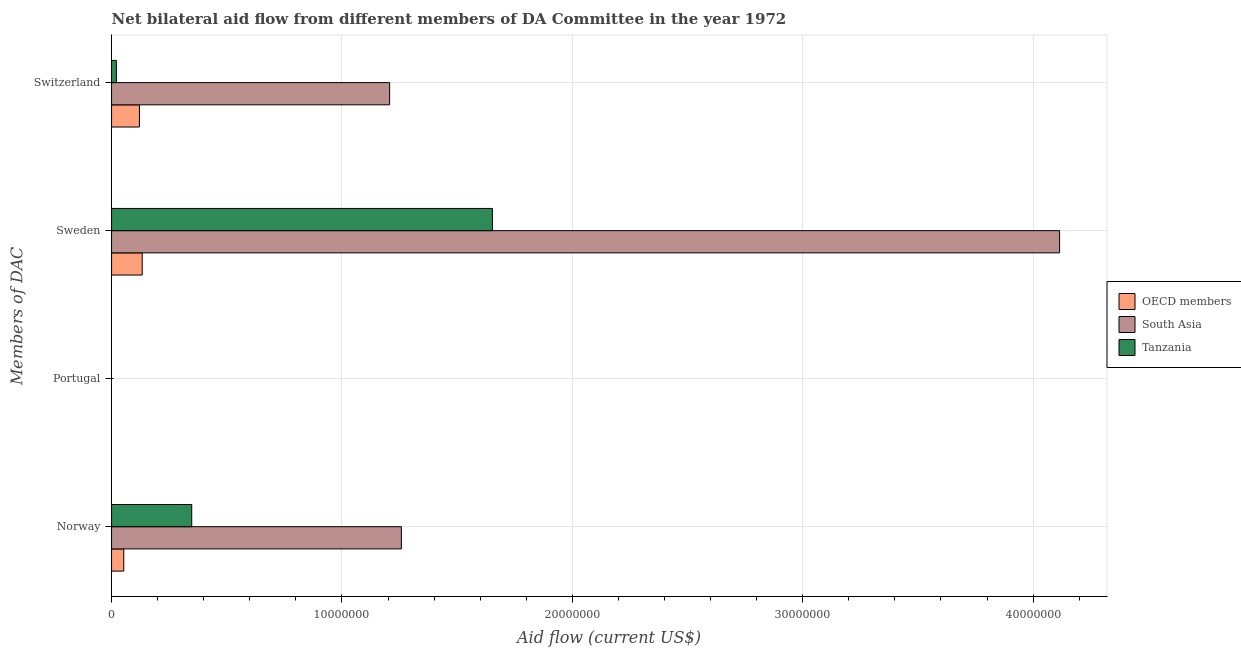What is the label of the 1st group of bars from the top?
Offer a very short reply. Switzerland. What is the amount of aid given by sweden in Tanzania?
Offer a very short reply. 1.65e+07. Across all countries, what is the maximum amount of aid given by norway?
Your answer should be very brief. 1.26e+07. Across all countries, what is the minimum amount of aid given by sweden?
Offer a terse response. 1.33e+06. What is the total amount of aid given by sweden in the graph?
Offer a terse response. 5.90e+07. What is the difference between the amount of aid given by norway in OECD members and that in Tanzania?
Ensure brevity in your answer.  -2.95e+06. What is the difference between the amount of aid given by switzerland in OECD members and the amount of aid given by portugal in South Asia?
Provide a succinct answer. 1.21e+06. What is the average amount of aid given by norway per country?
Ensure brevity in your answer.  5.53e+06. What is the difference between the amount of aid given by switzerland and amount of aid given by norway in OECD members?
Your answer should be very brief. 6.80e+05. What is the ratio of the amount of aid given by norway in Tanzania to that in South Asia?
Make the answer very short. 0.28. What is the difference between the highest and the second highest amount of aid given by switzerland?
Give a very brief answer. 1.09e+07. What is the difference between the highest and the lowest amount of aid given by norway?
Keep it short and to the point. 1.20e+07. In how many countries, is the amount of aid given by norway greater than the average amount of aid given by norway taken over all countries?
Ensure brevity in your answer.  1. Is the sum of the amount of aid given by norway in OECD members and South Asia greater than the maximum amount of aid given by portugal across all countries?
Your answer should be compact. Yes. Where does the legend appear in the graph?
Provide a succinct answer. Center right. What is the title of the graph?
Offer a very short reply. Net bilateral aid flow from different members of DA Committee in the year 1972. What is the label or title of the X-axis?
Keep it short and to the point. Aid flow (current US$). What is the label or title of the Y-axis?
Offer a terse response. Members of DAC. What is the Aid flow (current US$) in OECD members in Norway?
Your answer should be compact. 5.30e+05. What is the Aid flow (current US$) in South Asia in Norway?
Your answer should be compact. 1.26e+07. What is the Aid flow (current US$) of Tanzania in Norway?
Give a very brief answer. 3.48e+06. What is the Aid flow (current US$) of OECD members in Portugal?
Your answer should be very brief. Nan. What is the Aid flow (current US$) of South Asia in Portugal?
Give a very brief answer. Nan. What is the Aid flow (current US$) of Tanzania in Portugal?
Provide a succinct answer. Nan. What is the Aid flow (current US$) of OECD members in Sweden?
Keep it short and to the point. 1.33e+06. What is the Aid flow (current US$) in South Asia in Sweden?
Keep it short and to the point. 4.12e+07. What is the Aid flow (current US$) of Tanzania in Sweden?
Ensure brevity in your answer.  1.65e+07. What is the Aid flow (current US$) in OECD members in Switzerland?
Offer a terse response. 1.21e+06. What is the Aid flow (current US$) of South Asia in Switzerland?
Offer a very short reply. 1.21e+07. Across all Members of DAC, what is the maximum Aid flow (current US$) in OECD members?
Provide a succinct answer. 1.33e+06. Across all Members of DAC, what is the maximum Aid flow (current US$) of South Asia?
Your answer should be very brief. 4.12e+07. Across all Members of DAC, what is the maximum Aid flow (current US$) in Tanzania?
Your response must be concise. 1.65e+07. Across all Members of DAC, what is the minimum Aid flow (current US$) of OECD members?
Offer a very short reply. 5.30e+05. Across all Members of DAC, what is the minimum Aid flow (current US$) in South Asia?
Ensure brevity in your answer.  1.21e+07. Across all Members of DAC, what is the minimum Aid flow (current US$) of Tanzania?
Give a very brief answer. 2.10e+05. What is the total Aid flow (current US$) in OECD members in the graph?
Your response must be concise. 3.07e+06. What is the total Aid flow (current US$) in South Asia in the graph?
Your answer should be very brief. 6.58e+07. What is the total Aid flow (current US$) in Tanzania in the graph?
Give a very brief answer. 2.02e+07. What is the difference between the Aid flow (current US$) in OECD members in Norway and that in Portugal?
Make the answer very short. Nan. What is the difference between the Aid flow (current US$) in South Asia in Norway and that in Portugal?
Offer a very short reply. Nan. What is the difference between the Aid flow (current US$) of Tanzania in Norway and that in Portugal?
Your answer should be very brief. Nan. What is the difference between the Aid flow (current US$) of OECD members in Norway and that in Sweden?
Provide a short and direct response. -8.00e+05. What is the difference between the Aid flow (current US$) in South Asia in Norway and that in Sweden?
Keep it short and to the point. -2.86e+07. What is the difference between the Aid flow (current US$) of Tanzania in Norway and that in Sweden?
Your answer should be very brief. -1.30e+07. What is the difference between the Aid flow (current US$) of OECD members in Norway and that in Switzerland?
Give a very brief answer. -6.80e+05. What is the difference between the Aid flow (current US$) of South Asia in Norway and that in Switzerland?
Ensure brevity in your answer.  5.10e+05. What is the difference between the Aid flow (current US$) of Tanzania in Norway and that in Switzerland?
Provide a short and direct response. 3.27e+06. What is the difference between the Aid flow (current US$) in OECD members in Portugal and that in Sweden?
Give a very brief answer. Nan. What is the difference between the Aid flow (current US$) in South Asia in Portugal and that in Sweden?
Your answer should be compact. Nan. What is the difference between the Aid flow (current US$) of Tanzania in Portugal and that in Sweden?
Provide a short and direct response. Nan. What is the difference between the Aid flow (current US$) of OECD members in Portugal and that in Switzerland?
Keep it short and to the point. Nan. What is the difference between the Aid flow (current US$) of South Asia in Portugal and that in Switzerland?
Offer a very short reply. Nan. What is the difference between the Aid flow (current US$) in Tanzania in Portugal and that in Switzerland?
Make the answer very short. Nan. What is the difference between the Aid flow (current US$) of OECD members in Sweden and that in Switzerland?
Your answer should be compact. 1.20e+05. What is the difference between the Aid flow (current US$) of South Asia in Sweden and that in Switzerland?
Offer a terse response. 2.91e+07. What is the difference between the Aid flow (current US$) of Tanzania in Sweden and that in Switzerland?
Provide a succinct answer. 1.63e+07. What is the difference between the Aid flow (current US$) in OECD members in Norway and the Aid flow (current US$) in South Asia in Portugal?
Provide a short and direct response. Nan. What is the difference between the Aid flow (current US$) in OECD members in Norway and the Aid flow (current US$) in Tanzania in Portugal?
Provide a short and direct response. Nan. What is the difference between the Aid flow (current US$) of South Asia in Norway and the Aid flow (current US$) of Tanzania in Portugal?
Your answer should be compact. Nan. What is the difference between the Aid flow (current US$) of OECD members in Norway and the Aid flow (current US$) of South Asia in Sweden?
Keep it short and to the point. -4.06e+07. What is the difference between the Aid flow (current US$) of OECD members in Norway and the Aid flow (current US$) of Tanzania in Sweden?
Offer a very short reply. -1.60e+07. What is the difference between the Aid flow (current US$) in South Asia in Norway and the Aid flow (current US$) in Tanzania in Sweden?
Your answer should be compact. -3.95e+06. What is the difference between the Aid flow (current US$) of OECD members in Norway and the Aid flow (current US$) of South Asia in Switzerland?
Give a very brief answer. -1.15e+07. What is the difference between the Aid flow (current US$) in OECD members in Norway and the Aid flow (current US$) in Tanzania in Switzerland?
Your answer should be very brief. 3.20e+05. What is the difference between the Aid flow (current US$) in South Asia in Norway and the Aid flow (current US$) in Tanzania in Switzerland?
Your answer should be compact. 1.24e+07. What is the difference between the Aid flow (current US$) in OECD members in Portugal and the Aid flow (current US$) in South Asia in Sweden?
Provide a succinct answer. Nan. What is the difference between the Aid flow (current US$) of OECD members in Portugal and the Aid flow (current US$) of Tanzania in Sweden?
Provide a short and direct response. Nan. What is the difference between the Aid flow (current US$) in South Asia in Portugal and the Aid flow (current US$) in Tanzania in Sweden?
Give a very brief answer. Nan. What is the difference between the Aid flow (current US$) in OECD members in Portugal and the Aid flow (current US$) in South Asia in Switzerland?
Offer a terse response. Nan. What is the difference between the Aid flow (current US$) of OECD members in Portugal and the Aid flow (current US$) of Tanzania in Switzerland?
Give a very brief answer. Nan. What is the difference between the Aid flow (current US$) in South Asia in Portugal and the Aid flow (current US$) in Tanzania in Switzerland?
Keep it short and to the point. Nan. What is the difference between the Aid flow (current US$) of OECD members in Sweden and the Aid flow (current US$) of South Asia in Switzerland?
Your answer should be compact. -1.07e+07. What is the difference between the Aid flow (current US$) in OECD members in Sweden and the Aid flow (current US$) in Tanzania in Switzerland?
Provide a short and direct response. 1.12e+06. What is the difference between the Aid flow (current US$) of South Asia in Sweden and the Aid flow (current US$) of Tanzania in Switzerland?
Your response must be concise. 4.09e+07. What is the average Aid flow (current US$) of OECD members per Members of DAC?
Ensure brevity in your answer.  7.68e+05. What is the average Aid flow (current US$) in South Asia per Members of DAC?
Offer a terse response. 1.64e+07. What is the average Aid flow (current US$) of Tanzania per Members of DAC?
Offer a terse response. 5.06e+06. What is the difference between the Aid flow (current US$) in OECD members and Aid flow (current US$) in South Asia in Norway?
Give a very brief answer. -1.20e+07. What is the difference between the Aid flow (current US$) of OECD members and Aid flow (current US$) of Tanzania in Norway?
Offer a terse response. -2.95e+06. What is the difference between the Aid flow (current US$) of South Asia and Aid flow (current US$) of Tanzania in Norway?
Ensure brevity in your answer.  9.10e+06. What is the difference between the Aid flow (current US$) in OECD members and Aid flow (current US$) in South Asia in Portugal?
Offer a very short reply. Nan. What is the difference between the Aid flow (current US$) in OECD members and Aid flow (current US$) in Tanzania in Portugal?
Your answer should be very brief. Nan. What is the difference between the Aid flow (current US$) of South Asia and Aid flow (current US$) of Tanzania in Portugal?
Offer a terse response. Nan. What is the difference between the Aid flow (current US$) in OECD members and Aid flow (current US$) in South Asia in Sweden?
Make the answer very short. -3.98e+07. What is the difference between the Aid flow (current US$) in OECD members and Aid flow (current US$) in Tanzania in Sweden?
Offer a terse response. -1.52e+07. What is the difference between the Aid flow (current US$) in South Asia and Aid flow (current US$) in Tanzania in Sweden?
Your answer should be very brief. 2.46e+07. What is the difference between the Aid flow (current US$) in OECD members and Aid flow (current US$) in South Asia in Switzerland?
Your answer should be very brief. -1.09e+07. What is the difference between the Aid flow (current US$) of South Asia and Aid flow (current US$) of Tanzania in Switzerland?
Keep it short and to the point. 1.19e+07. What is the ratio of the Aid flow (current US$) of OECD members in Norway to that in Portugal?
Make the answer very short. Nan. What is the ratio of the Aid flow (current US$) of South Asia in Norway to that in Portugal?
Provide a succinct answer. Nan. What is the ratio of the Aid flow (current US$) of Tanzania in Norway to that in Portugal?
Provide a succinct answer. Nan. What is the ratio of the Aid flow (current US$) of OECD members in Norway to that in Sweden?
Make the answer very short. 0.4. What is the ratio of the Aid flow (current US$) in South Asia in Norway to that in Sweden?
Keep it short and to the point. 0.31. What is the ratio of the Aid flow (current US$) in Tanzania in Norway to that in Sweden?
Offer a terse response. 0.21. What is the ratio of the Aid flow (current US$) in OECD members in Norway to that in Switzerland?
Provide a succinct answer. 0.44. What is the ratio of the Aid flow (current US$) of South Asia in Norway to that in Switzerland?
Offer a very short reply. 1.04. What is the ratio of the Aid flow (current US$) in Tanzania in Norway to that in Switzerland?
Keep it short and to the point. 16.57. What is the ratio of the Aid flow (current US$) of OECD members in Portugal to that in Sweden?
Give a very brief answer. Nan. What is the ratio of the Aid flow (current US$) in South Asia in Portugal to that in Sweden?
Ensure brevity in your answer.  Nan. What is the ratio of the Aid flow (current US$) of Tanzania in Portugal to that in Sweden?
Offer a terse response. Nan. What is the ratio of the Aid flow (current US$) in OECD members in Portugal to that in Switzerland?
Provide a succinct answer. Nan. What is the ratio of the Aid flow (current US$) of South Asia in Portugal to that in Switzerland?
Offer a terse response. Nan. What is the ratio of the Aid flow (current US$) of Tanzania in Portugal to that in Switzerland?
Ensure brevity in your answer.  Nan. What is the ratio of the Aid flow (current US$) of OECD members in Sweden to that in Switzerland?
Provide a succinct answer. 1.1. What is the ratio of the Aid flow (current US$) in South Asia in Sweden to that in Switzerland?
Offer a terse response. 3.41. What is the ratio of the Aid flow (current US$) in Tanzania in Sweden to that in Switzerland?
Offer a very short reply. 78.71. What is the difference between the highest and the second highest Aid flow (current US$) in South Asia?
Your answer should be compact. 2.86e+07. What is the difference between the highest and the second highest Aid flow (current US$) of Tanzania?
Give a very brief answer. 1.30e+07. What is the difference between the highest and the lowest Aid flow (current US$) of OECD members?
Your response must be concise. 8.00e+05. What is the difference between the highest and the lowest Aid flow (current US$) of South Asia?
Your response must be concise. 2.91e+07. What is the difference between the highest and the lowest Aid flow (current US$) in Tanzania?
Your response must be concise. 1.63e+07. 